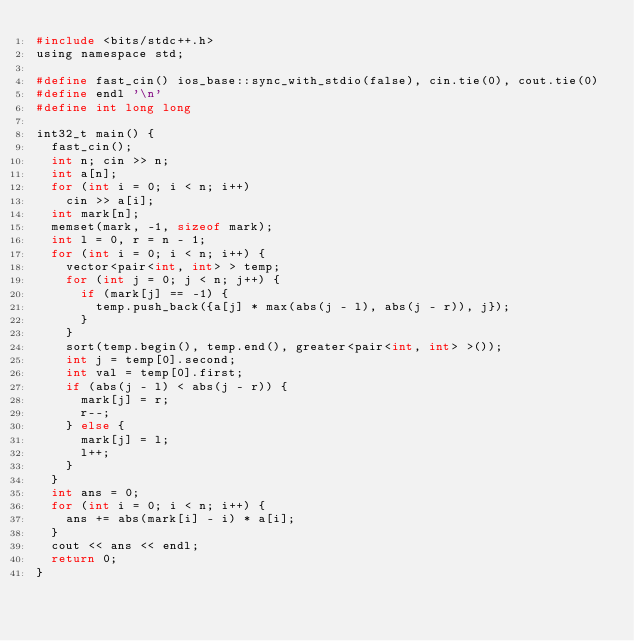Convert code to text. <code><loc_0><loc_0><loc_500><loc_500><_C_>#include <bits/stdc++.h>
using namespace std;
						
#define fast_cin() ios_base::sync_with_stdio(false), cin.tie(0), cout.tie(0)
#define endl '\n'
#define int long long
				
int32_t main() {
	fast_cin();  
	int n; cin >> n;
	int a[n];
	for (int i = 0; i < n; i++)
		cin >> a[i];
	int mark[n];
	memset(mark, -1, sizeof mark);
	int l = 0, r = n - 1;
	for (int i = 0; i < n; i++) {
		vector<pair<int, int> > temp;
		for (int j = 0; j < n; j++) {
			if (mark[j] == -1) {
				temp.push_back({a[j] * max(abs(j - l), abs(j - r)), j});
			}
		}
		sort(temp.begin(), temp.end(), greater<pair<int, int> >());
		int j = temp[0].second;
		int val = temp[0].first;
		if (abs(j - l) < abs(j - r)) {
			mark[j] = r;
			r--;
		} else {
			mark[j] = l;
			l++;
		}
	}
	int ans = 0;
	for (int i = 0; i < n; i++) {
		ans += abs(mark[i] - i) * a[i];
	}
	cout << ans << endl;
	return 0;
}</code> 